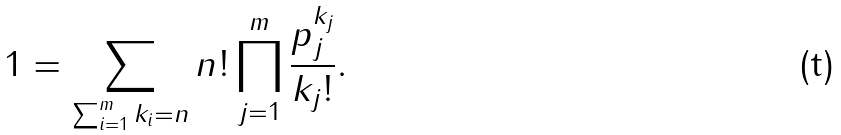<formula> <loc_0><loc_0><loc_500><loc_500>1 = \sum _ { \sum _ { i = 1 } ^ { m } k _ { i } = n } n ! \prod _ { j = 1 } ^ { m } \frac { p _ { j } ^ { k _ { j } } } { k _ { j } ! } .</formula> 